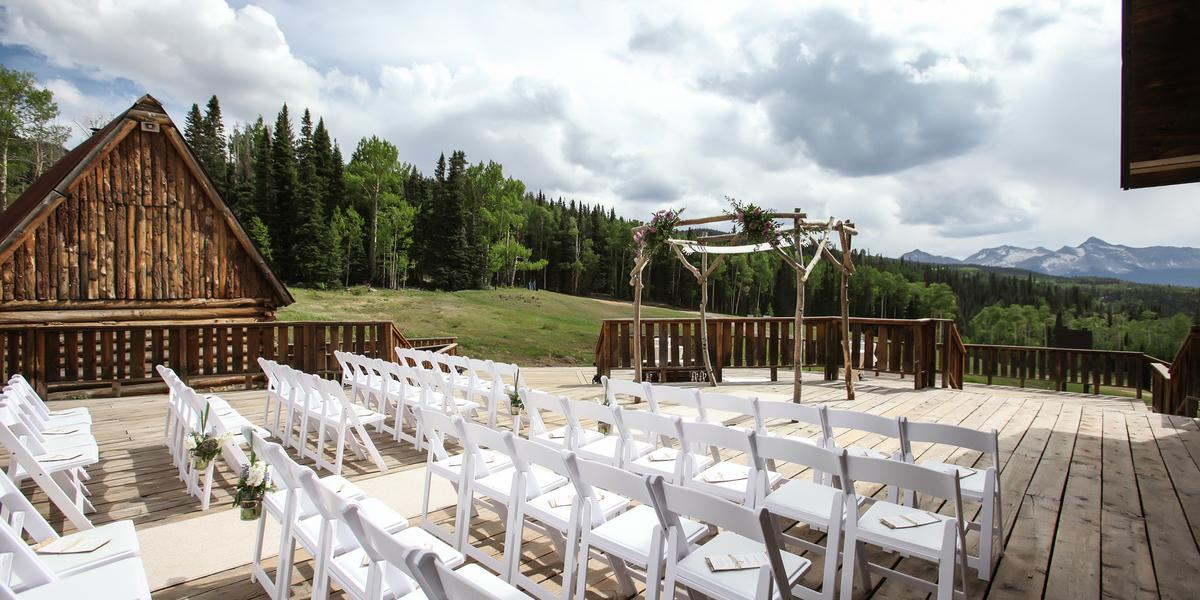Can you describe the setting and ambiance that this outdoor wedding venue provides? The venue is set amidst a panoramic backdrop of lush green forests and distant mountains, creating a striking and serene ambiance. The rustic wooden architecture of the cabin and the natural landscape offer a quintessentially pastoral and tranquil setting, ideal for an outdoor wedding. This location not only provides a visually stunning setting but also a peaceful ambiance, where nature's beauty adds to the solemnity and joy of the occasion. 